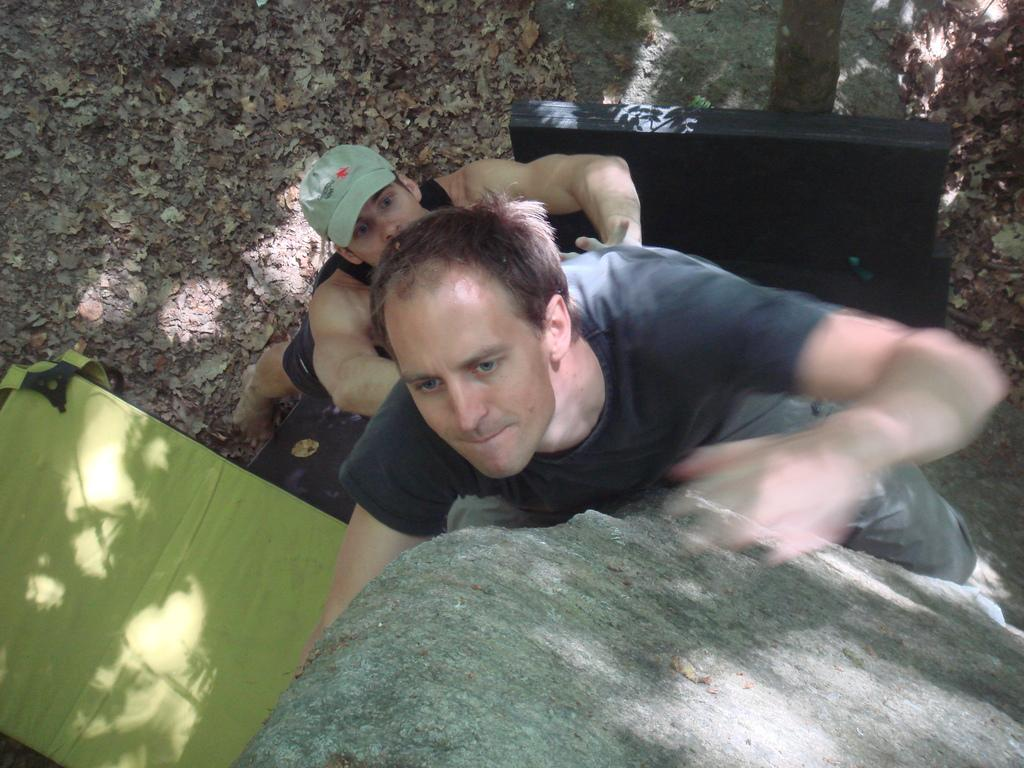What are the persons in the image doing? The persons in the image are climbing the tree. What can be seen in the background of the image? There are leaves visible in the background of the image. What type of duck can be seen swimming in the tree in the image? There is no duck present in the image, and ducks do not swim in trees. 